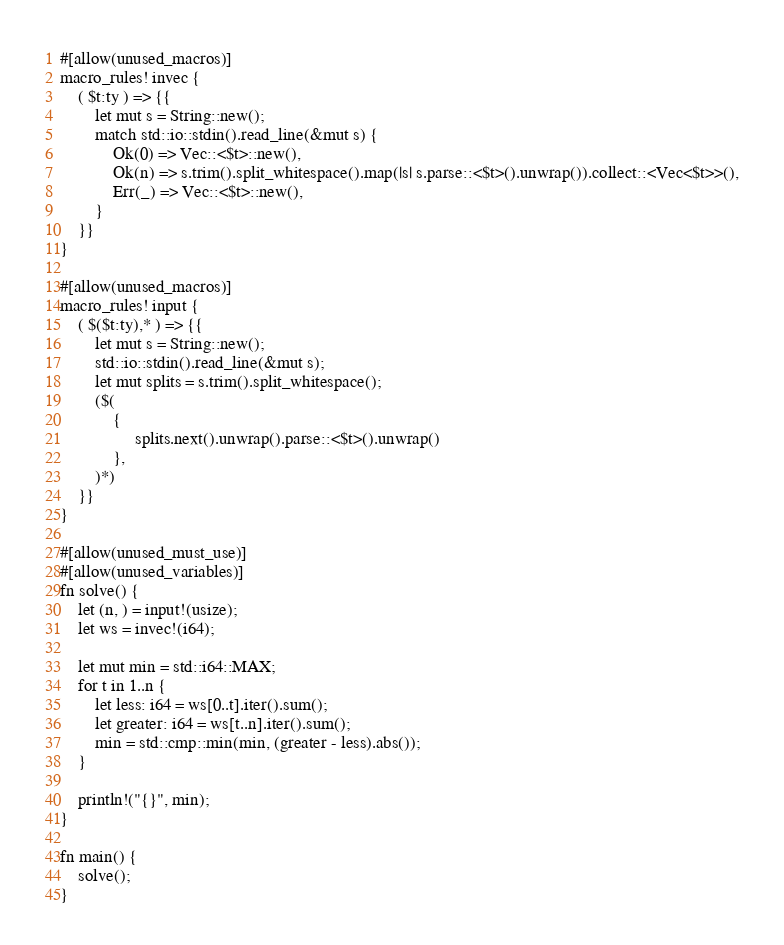<code> <loc_0><loc_0><loc_500><loc_500><_Rust_>#[allow(unused_macros)]
macro_rules! invec {
    ( $t:ty ) => {{
        let mut s = String::new();
        match std::io::stdin().read_line(&mut s) {
            Ok(0) => Vec::<$t>::new(),
            Ok(n) => s.trim().split_whitespace().map(|s| s.parse::<$t>().unwrap()).collect::<Vec<$t>>(),
            Err(_) => Vec::<$t>::new(),
        }
    }}
}

#[allow(unused_macros)]
macro_rules! input {
    ( $($t:ty),* ) => {{
        let mut s = String::new();
        std::io::stdin().read_line(&mut s);
        let mut splits = s.trim().split_whitespace();
        ($(
            {
                 splits.next().unwrap().parse::<$t>().unwrap()
            },
        )*)
    }}
}

#[allow(unused_must_use)]
#[allow(unused_variables)]
fn solve() {
    let (n, ) = input!(usize);
    let ws = invec!(i64);

    let mut min = std::i64::MAX;
    for t in 1..n {
        let less: i64 = ws[0..t].iter().sum();
        let greater: i64 = ws[t..n].iter().sum();
        min = std::cmp::min(min, (greater - less).abs());
    }

    println!("{}", min);
}

fn main() {
    solve();
}
</code> 